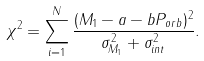<formula> <loc_0><loc_0><loc_500><loc_500>\chi ^ { 2 } = \sum _ { i = 1 } ^ { N } \frac { ( M _ { 1 } - a - b P _ { o r b } ) ^ { 2 } } { \sigma ^ { 2 } _ { M _ { 1 } } + \sigma ^ { 2 } _ { i n t } } .</formula> 